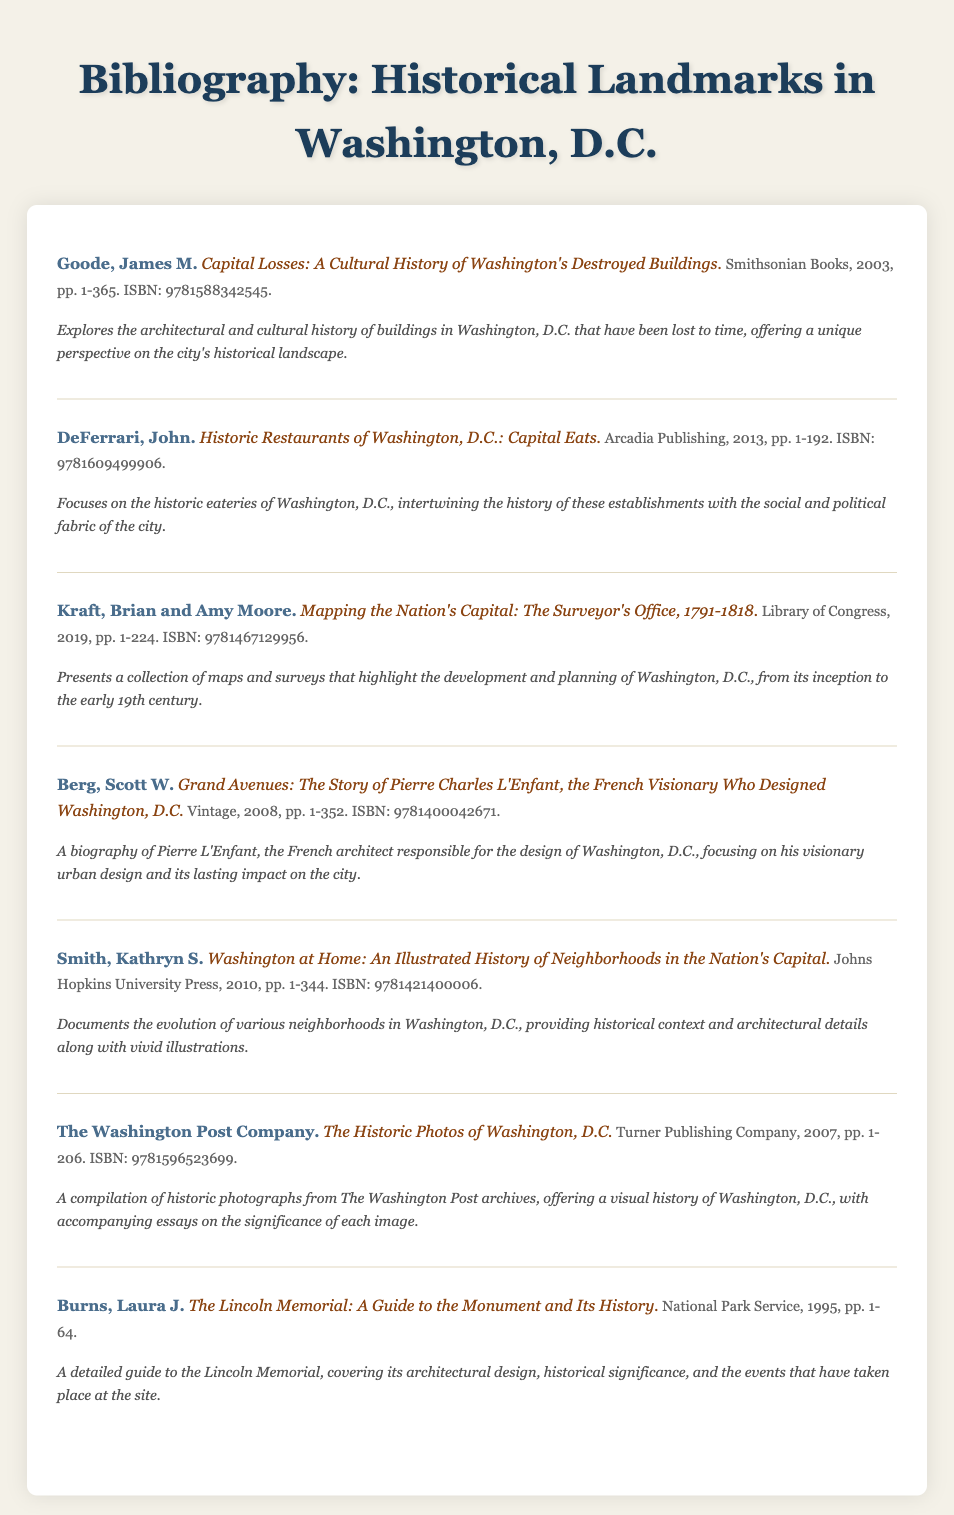What is the title of James M. Goode's work? The title of James M. Goode's work is "Capital Losses: A Cultural History of Washington's Destroyed Buildings."
Answer: Capital Losses: A Cultural History of Washington's Destroyed Buildings How many pages does "Historic Restaurants of Washington, D.C." have? The work "Historic Restaurants of Washington, D.C." has 192 pages.
Answer: 192 What is the ISBN of "Washington at Home"? The ISBN of "Washington at Home" is 9781421400006.
Answer: 9781421400006 Who authored "The Lincoln Memorial: A Guide to the Monument and Its History"? The author of that work is Laura J. Burns.
Answer: Laura J. Burns What year was "Grand Avenues: The Story of Pierre Charles L'Enfant" published? "Grand Avenues" was published in 2008.
Answer: 2008 Which publisher released "Mapping the Nation's Capital"? The publisher of "Mapping the Nation's Capital" is the Library of Congress.
Answer: Library of Congress How many entries are in the bibliography? There are seven entries in the bibliography.
Answer: Seven entries What kind of history does "The Historic Photos of Washington, D.C." offer? It offers a visual history of Washington, D.C.
Answer: Visual history 